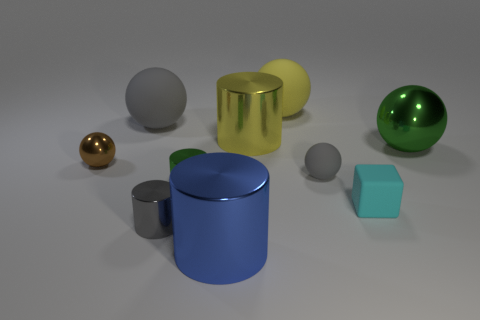What number of large objects are metallic things or gray matte blocks? 3 